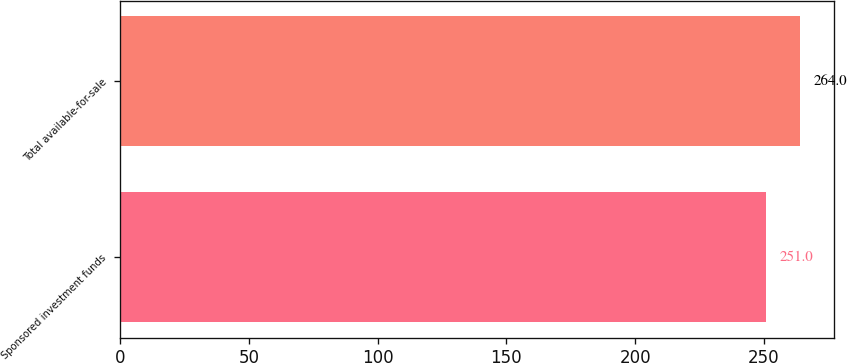<chart> <loc_0><loc_0><loc_500><loc_500><bar_chart><fcel>Sponsored investment funds<fcel>Total available-for-sale<nl><fcel>251<fcel>264<nl></chart> 